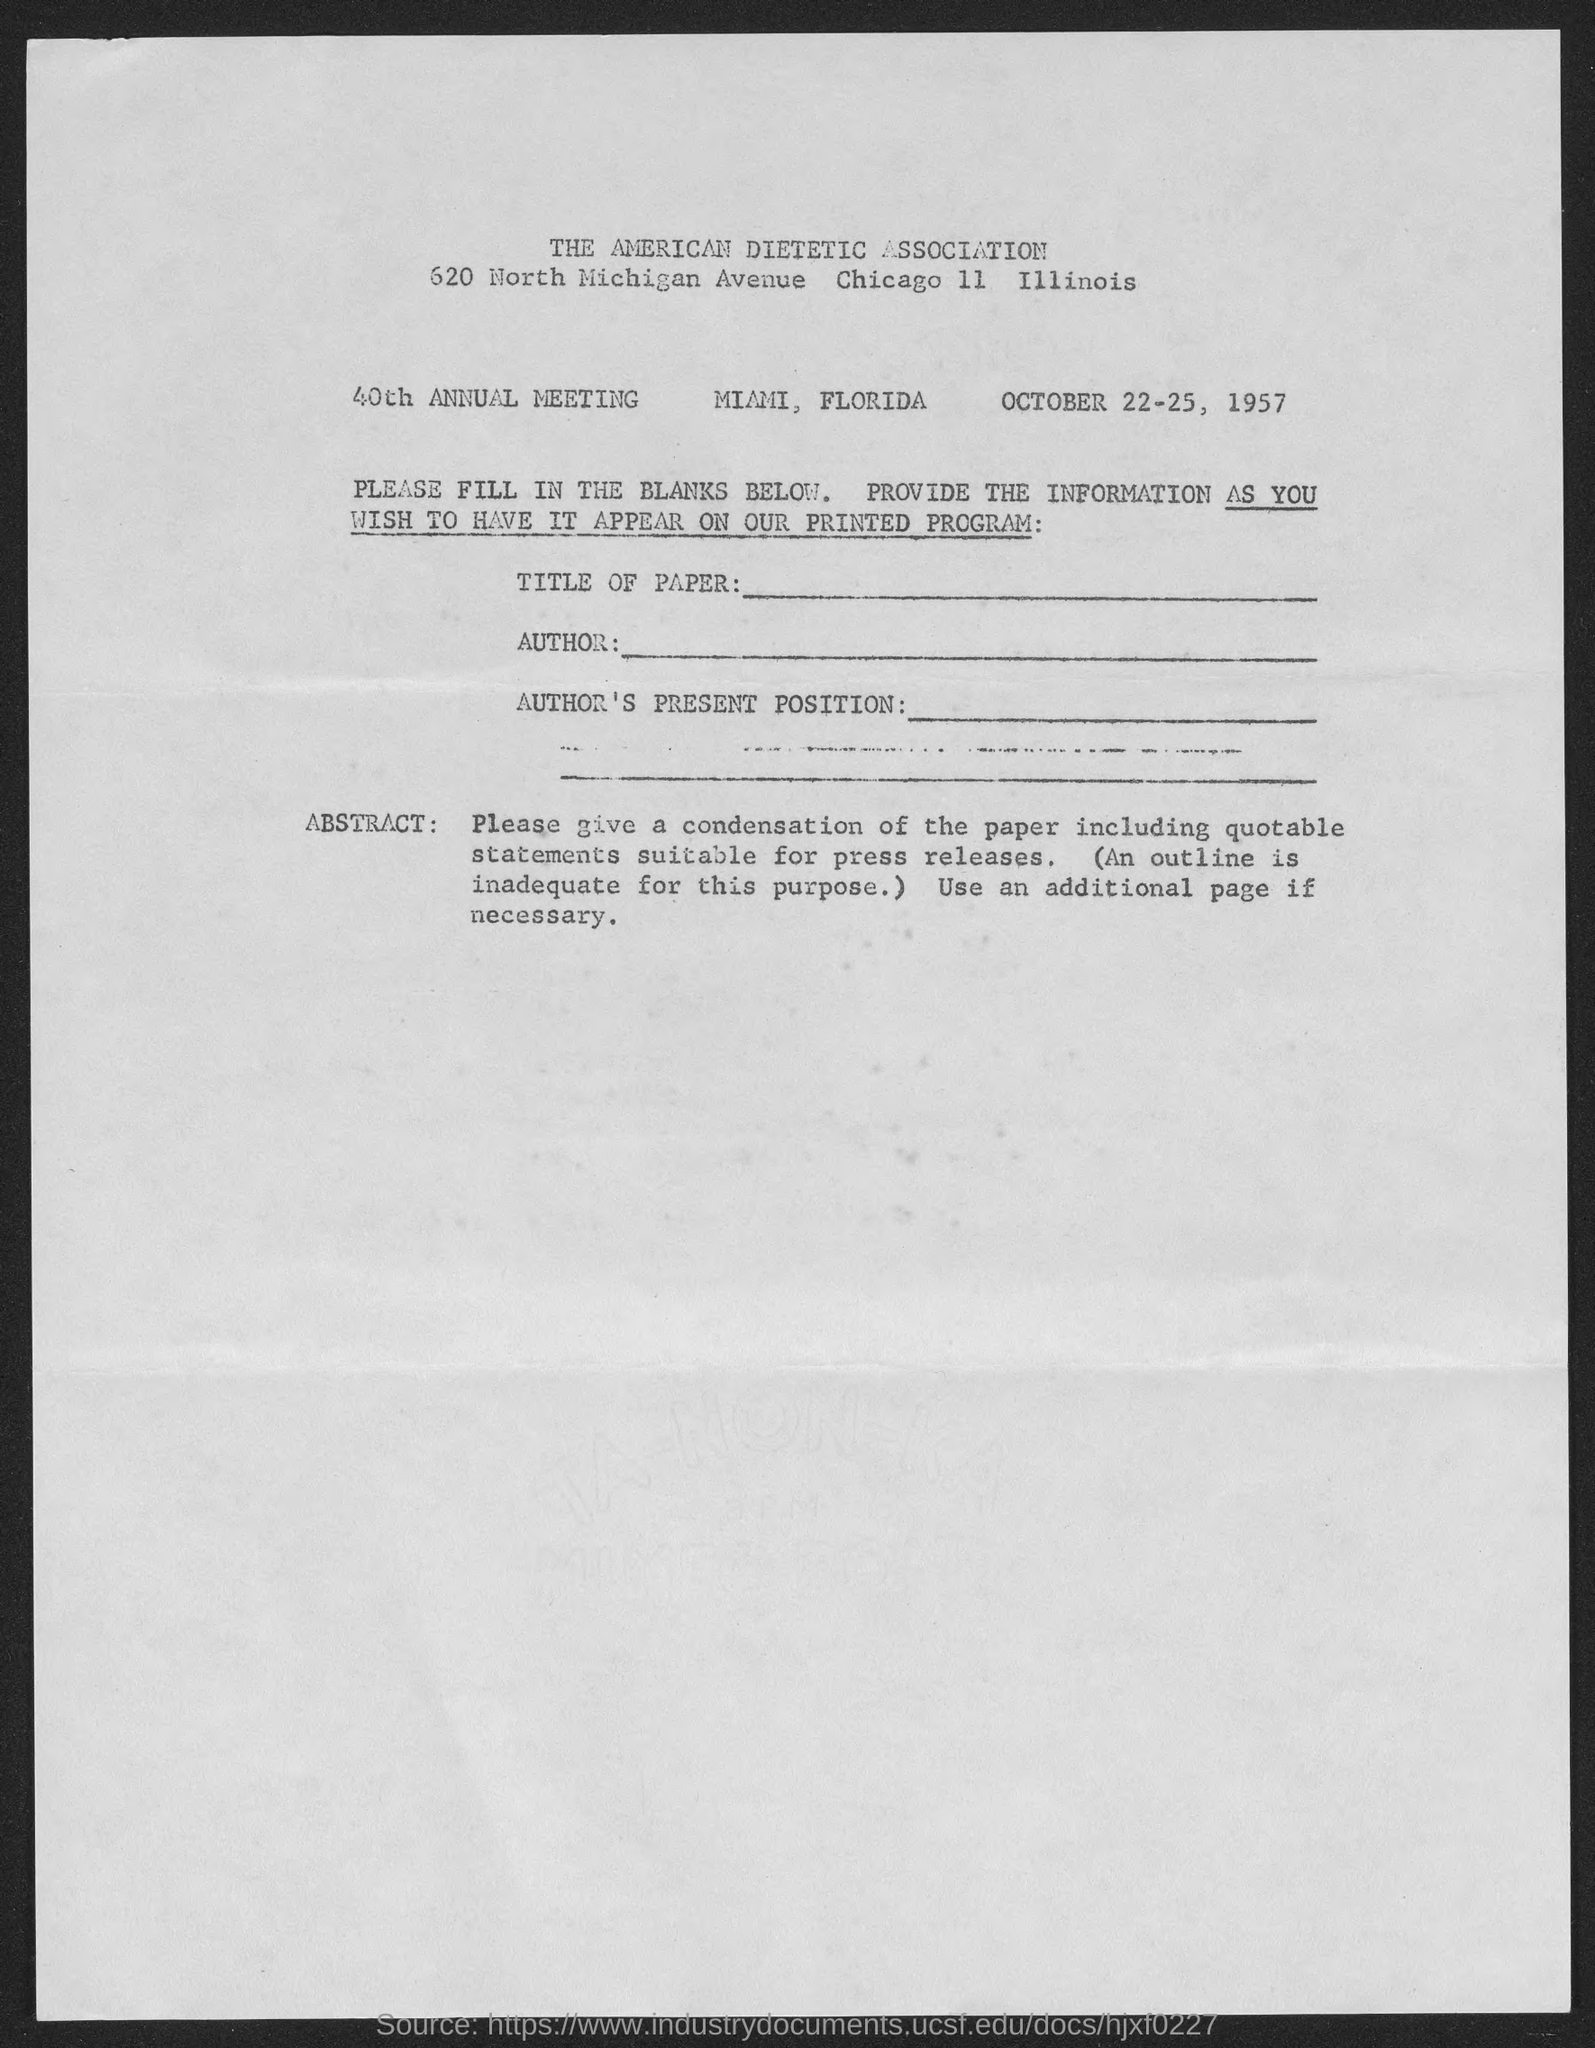Indicate a few pertinent items in this graphic. The address of the American Dietetic Association is 620 North Michigan Avenue, Chicago, Illinois 11. The American Dietetic Association is the name of the association conducting the meeting. The date given in the form is October 22-25, 1957. 